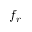<formula> <loc_0><loc_0><loc_500><loc_500>f _ { r }</formula> 